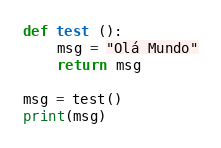Convert code to text. <code><loc_0><loc_0><loc_500><loc_500><_Python_>def test ():
    msg = "Olá Mundo"
    return msg

msg = test()
print(msg)</code> 